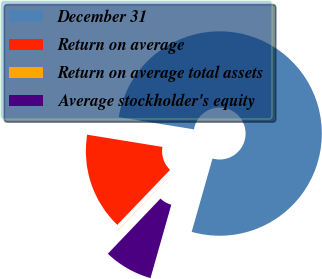Convert chart to OTSL. <chart><loc_0><loc_0><loc_500><loc_500><pie_chart><fcel>December 31<fcel>Return on average<fcel>Return on average total assets<fcel>Average stockholder's equity<nl><fcel>76.84%<fcel>15.4%<fcel>0.04%<fcel>7.72%<nl></chart> 